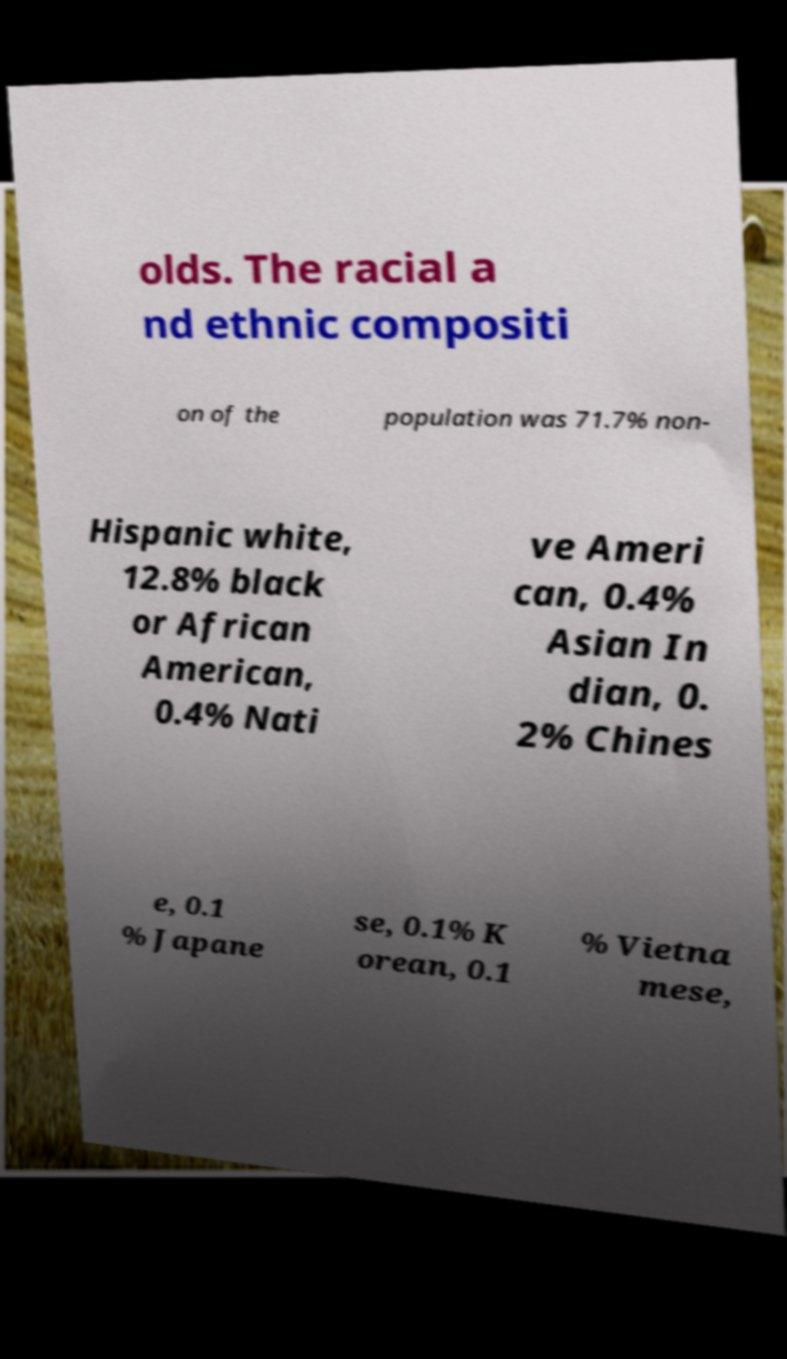Could you extract and type out the text from this image? olds. The racial a nd ethnic compositi on of the population was 71.7% non- Hispanic white, 12.8% black or African American, 0.4% Nati ve Ameri can, 0.4% Asian In dian, 0. 2% Chines e, 0.1 % Japane se, 0.1% K orean, 0.1 % Vietna mese, 